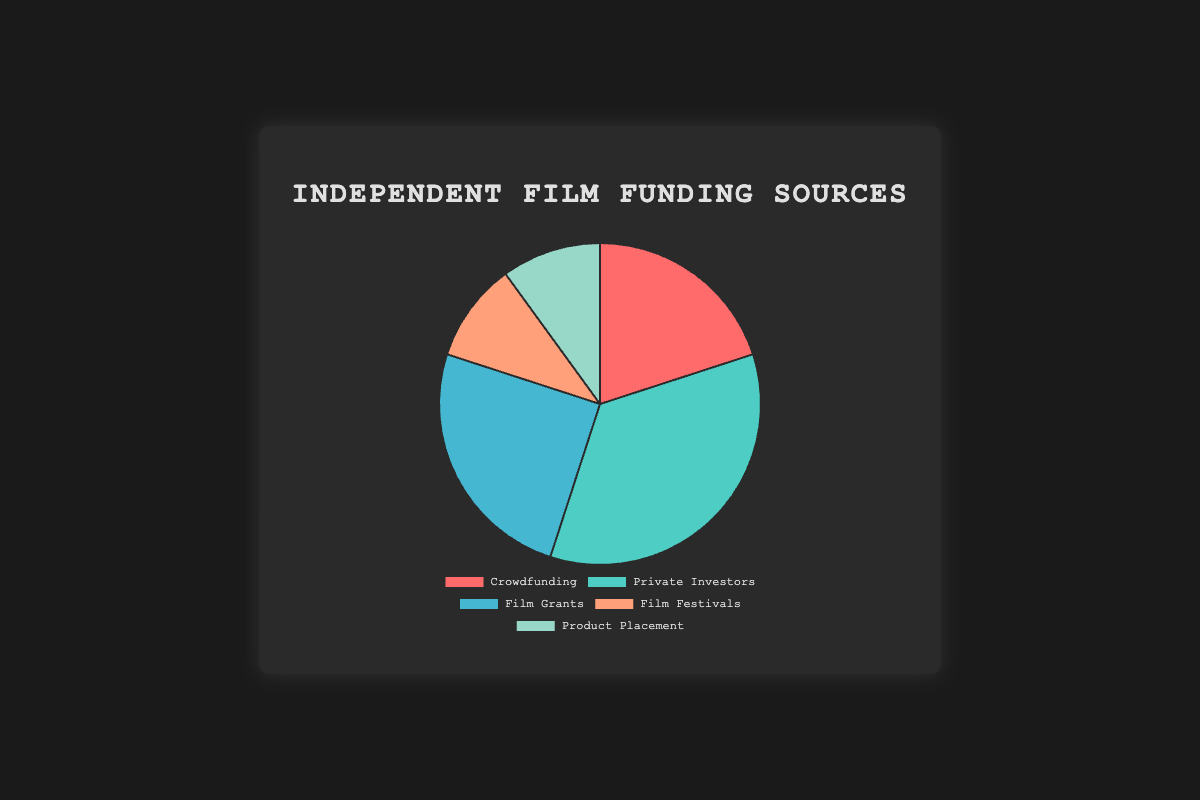What is the largest source of funding for independent films? By observing the segments in the pie chart, it's clear that the biggest portion is labeled "Private Investors." Its percentage value is shown to be 35%.
Answer: Private Investors Which sources share the smallest proportion of funding equally? The chart shows that "Film Festivals" and "Product Placement" occupy equal-sized segments. Both of these are labeled with a 10% share.
Answer: Film Festivals and Product Placement How much more funding does Private Investors contribute compared to Crowdfunding? Private Investors have a 35% share while Crowdfunding has a 20% share. The difference is 35% - 20% = 15%.
Answer: 15% What percentage of total funding is obtained from Crowdfunding and Film Grants combined? Adding the percentages of Crowdfunding (20%) and Film Grants (25%) results in a total of 20% + 25% = 45%.
Answer: 45% Which funding source is represented by the red slice? In the visual representation, the red slice is typically associated with Crowdfunding, which has a 20% share.
Answer: Crowdfunding Is the sum of funding from Film Festivals and Product Placement less than the amount from Film Grants? The combined funding from Film Festivals (10%) and Product Placement (10%) is 10% + 10% = 20%. Film Grants alone have 25%. Since 20% is less than 25%, the statement is true.
Answer: Yes What is the average percentage of all funding sources? Adding all the percentages gives 20% (Crowdfunding) + 35% (Private Investors) + 25% (Film Grants) + 10% (Film Festivals) + 10% (Product Placement) = 100%. The average is 100% / 5 = 20%.
Answer: 20% What is the difference between the second largest funding source and the second smallest funding source? The second largest is Film Grants with 25%. The second smallest is Crowdfunding with 20%. The difference is 25% - 20% = 5%.
Answer: 5% 